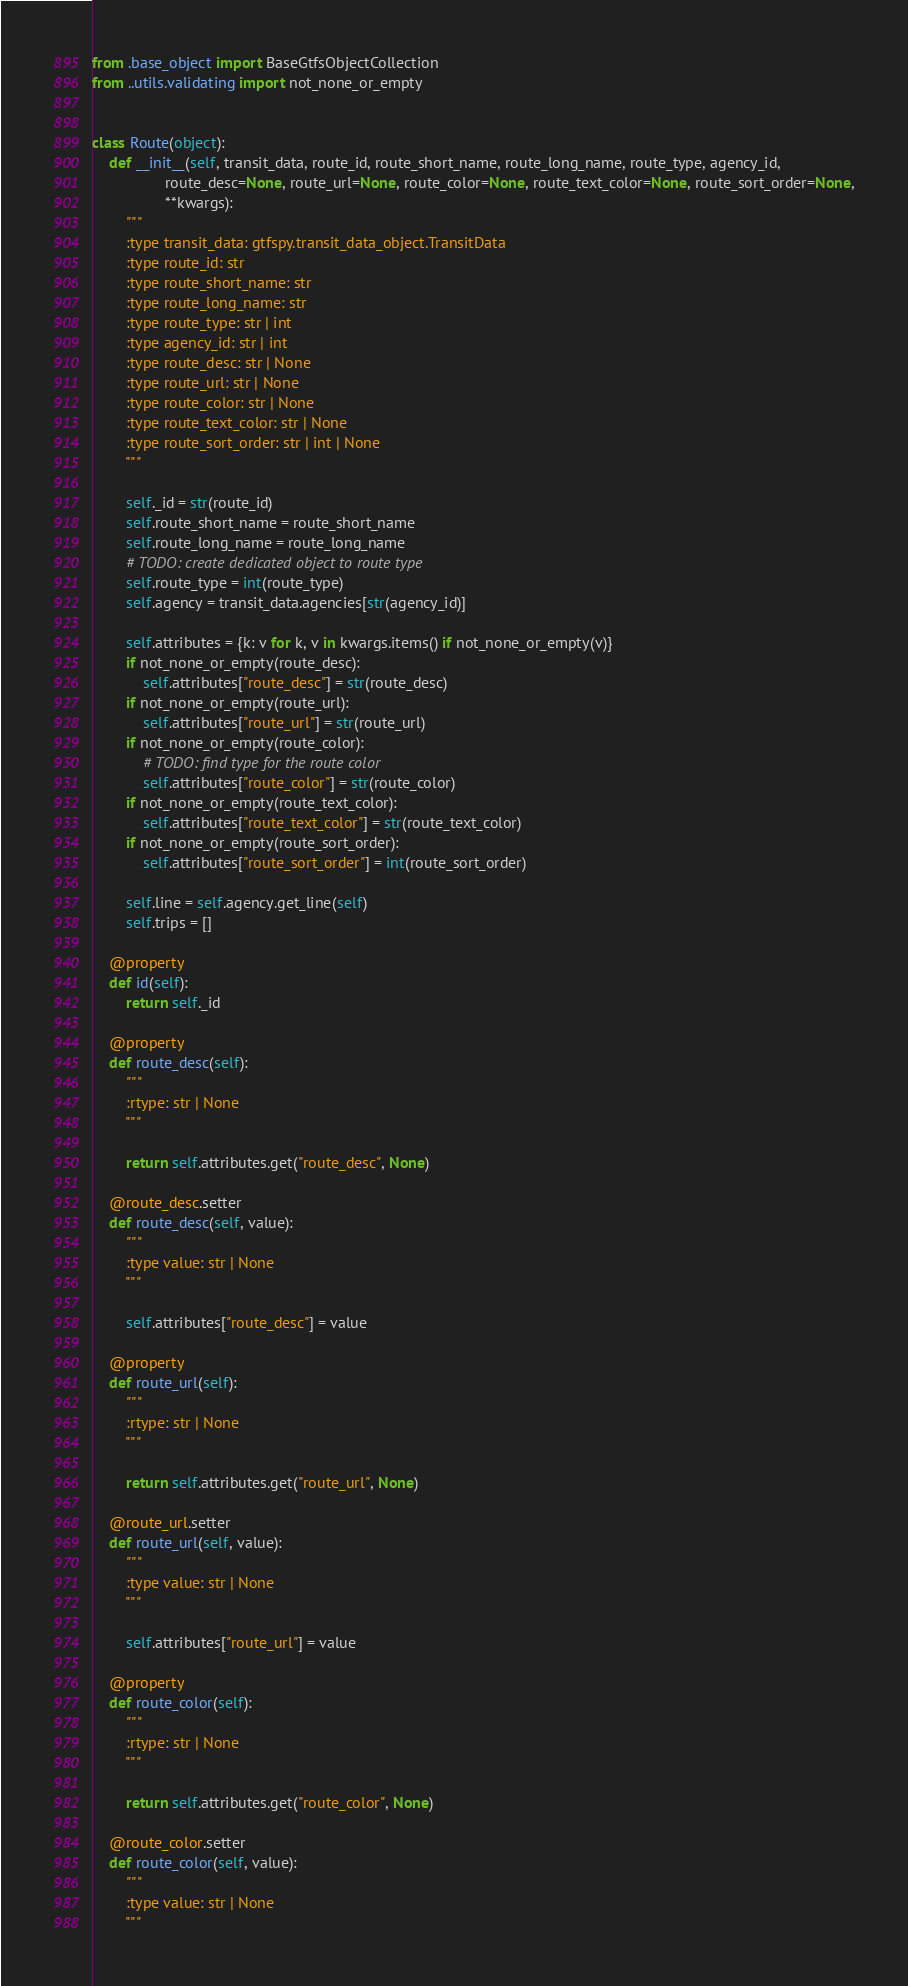Convert code to text. <code><loc_0><loc_0><loc_500><loc_500><_Python_>from .base_object import BaseGtfsObjectCollection
from ..utils.validating import not_none_or_empty


class Route(object):
    def __init__(self, transit_data, route_id, route_short_name, route_long_name, route_type, agency_id,
                 route_desc=None, route_url=None, route_color=None, route_text_color=None, route_sort_order=None,
                 **kwargs):
        """
        :type transit_data: gtfspy.transit_data_object.TransitData
        :type route_id: str
        :type route_short_name: str
        :type route_long_name: str
        :type route_type: str | int
        :type agency_id: str | int
        :type route_desc: str | None
        :type route_url: str | None
        :type route_color: str | None
        :type route_text_color: str | None
        :type route_sort_order: str | int | None
        """

        self._id = str(route_id)
        self.route_short_name = route_short_name
        self.route_long_name = route_long_name
        # TODO: create dedicated object to route type
        self.route_type = int(route_type)
        self.agency = transit_data.agencies[str(agency_id)]

        self.attributes = {k: v for k, v in kwargs.items() if not_none_or_empty(v)}
        if not_none_or_empty(route_desc):
            self.attributes["route_desc"] = str(route_desc)
        if not_none_or_empty(route_url):
            self.attributes["route_url"] = str(route_url)
        if not_none_or_empty(route_color):
            # TODO: find type for the route color
            self.attributes["route_color"] = str(route_color)
        if not_none_or_empty(route_text_color):
            self.attributes["route_text_color"] = str(route_text_color)
        if not_none_or_empty(route_sort_order):
            self.attributes["route_sort_order"] = int(route_sort_order)

        self.line = self.agency.get_line(self)
        self.trips = []

    @property
    def id(self):
        return self._id

    @property
    def route_desc(self):
        """
        :rtype: str | None
        """

        return self.attributes.get("route_desc", None)

    @route_desc.setter
    def route_desc(self, value):
        """
        :type value: str | None
        """

        self.attributes["route_desc"] = value

    @property
    def route_url(self):
        """
        :rtype: str | None
        """

        return self.attributes.get("route_url", None)

    @route_url.setter
    def route_url(self, value):
        """
        :type value: str | None
        """

        self.attributes["route_url"] = value

    @property
    def route_color(self):
        """
        :rtype: str | None
        """

        return self.attributes.get("route_color", None)

    @route_color.setter
    def route_color(self, value):
        """
        :type value: str | None
        """
</code> 